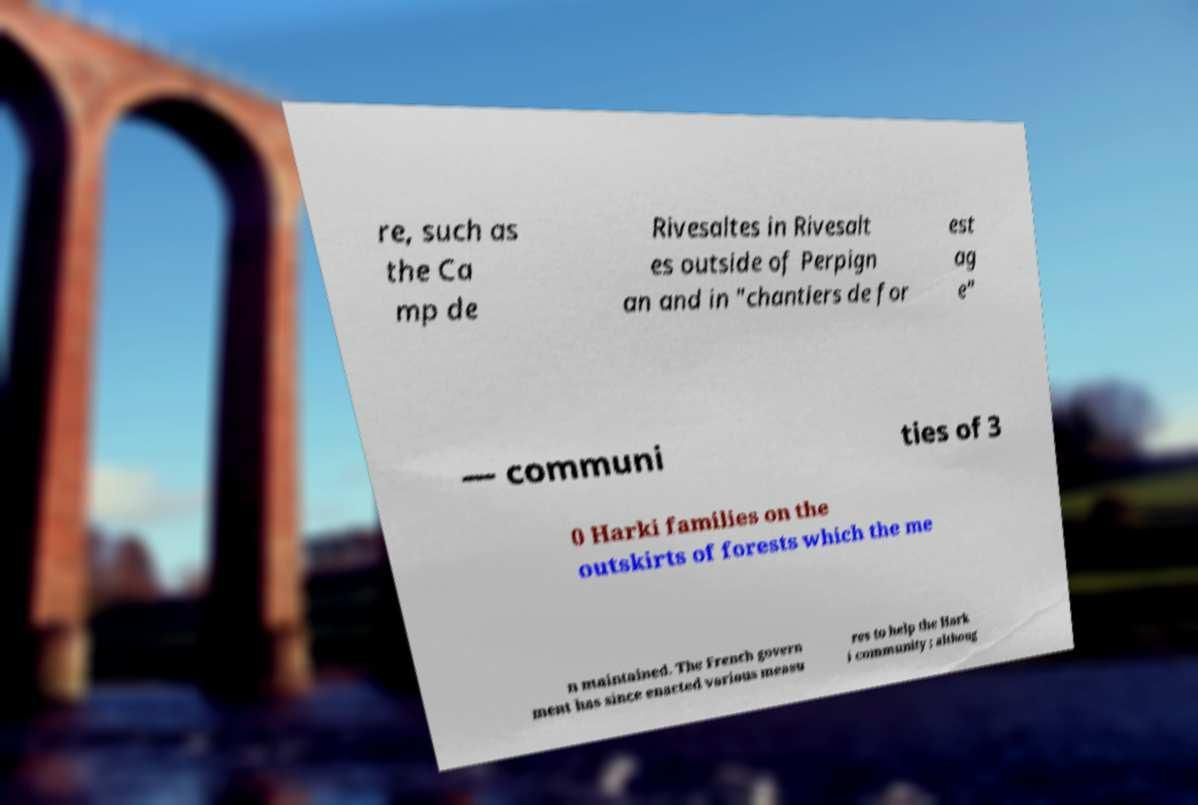Can you accurately transcribe the text from the provided image for me? re, such as the Ca mp de Rivesaltes in Rivesalt es outside of Perpign an and in "chantiers de for est ag e" — communi ties of 3 0 Harki families on the outskirts of forests which the me n maintained. The French govern ment has since enacted various measu res to help the Hark i community ; althoug 